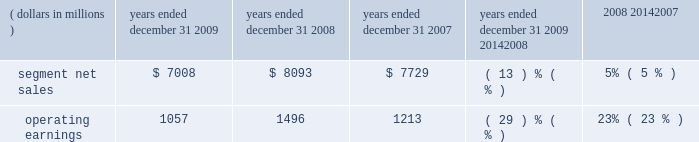Management 2019s discussion and analysis of financial condition and results of operations in 2008 , sales to the segment 2019s top five customers represented approximately 45% ( 45 % ) of the segment 2019s net sales .
The segment 2019s backlog was $ 2.3 billion at december 31 , 2008 , compared to $ 2.6 billion at december 31 , 2007 .
In 2008 , our digital video customers significantly increased their purchases of the segment 2019s products and services , primarily due to increased demand for digital entertainment devices , particularly ip and hd/dvr devices .
In february 2008 , the segment acquired the assets related to digital cable set-top products of zhejiang dahua digital technology co. , ltd and hangzhou image silicon ( known collectively as dahua digital ) , a developer , manufacturer and marketer of cable set-tops and related low-cost integrated circuits for the emerging chinese cable business .
The acquisition helped the segment strengthen its position in the rapidly growing cable market in china .
Enterprise mobility solutions segment the enterprise mobility solutions segment designs , manufactures , sells , installs and services analog and digital two-way radios , wireless lan and security products , voice and data communications products and systems for private networks , wireless broadband systems and end-to-end enterprise mobility solutions to a wide range of customers , including government and public safety agencies ( which , together with all sales to distributors of two-way communication products , are referred to as the 2018 2018government and public safety market 2019 2019 ) , as well as retail , energy and utilities , transportation , manufacturing , healthcare and other commercial customers ( which , collectively , are referred to as the 2018 2018commercial enterprise market 2019 2019 ) .
In 2009 , the segment 2019s net sales represented 32% ( 32 % ) of the company 2019s consolidated net sales , compared to 27% ( 27 % ) in 2008 and 21% ( 21 % ) in 2007 .
Years ended december 31 percent change ( dollars in millions ) 2009 2008 2007 2009 20142008 2008 20142007 .
Segment results 20142009 compared to 2008 in 2009 , the segment 2019s net sales were $ 7.0 billion , a decrease of 13% ( 13 % ) compared to net sales of $ 8.1 billion in 2008 .
The 13% ( 13 % ) decrease in net sales reflects a 21% ( 21 % ) decrease in net sales to the commercial enterprise market and a 10% ( 10 % ) decrease in net sales to the government and public safety market .
The decrease in net sales to the commercial enterprise market reflects decreased net sales in all regions .
The decrease in net sales to the government and public safety market was primarily driven by decreased net sales in emea , north america and latin america , partially offset by higher net sales in asia .
The segment 2019s overall net sales were lower in north america , emea and latin america and higher in asia the segment had operating earnings of $ 1.1 billion in 2009 , a decrease of 29% ( 29 % ) compared to operating earnings of $ 1.5 billion in 2008 .
The decrease in operating earnings was primarily due to a decrease in gross margin , driven by the 13% ( 13 % ) decrease in net sales and an unfavorable product mix .
Also contributing to the decrease in operating earnings was an increase in reorganization of business charges , relating primarily to higher employee severance costs .
These factors were partially offset by decreased sg&a expenses and r&d expenditures , primarily related to savings from cost-reduction initiatives .
As a percentage of net sales in 2009 as compared 2008 , gross margin decreased and r&d expenditures and sg&a expenses increased .
Net sales in north america continued to comprise a significant portion of the segment 2019s business , accounting for approximately 58% ( 58 % ) of the segment 2019s net sales in 2009 , compared to approximately 57% ( 57 % ) in 2008 .
The regional shift in 2009 as compared to 2008 reflects a 16% ( 16 % ) decline in net sales outside of north america and a 12% ( 12 % ) decline in net sales in north america .
The segment 2019s backlog was $ 2.4 billion at both december 31 , 2009 and december 31 , 2008 .
In our government and public safety market , we see a continued emphasis on mission-critical communication and homeland security solutions .
In 2009 , we led market innovation through the continued success of our mototrbo line and the delivery of the apx fffd family of products .
While spending by end customers in the segment 2019s government and public safety market is affected by government budgets at the national , state and local levels , we continue to see demand for large-scale mission critical communications systems .
In 2009 , we had significant wins across the globe , including several city and statewide communications systems in the united states , and continued success winning competitive projects with our tetra systems in europe , the middle east .
In 2007 what was the company 2019s consolidated net sales in millions? 
Computations: (7729 / 21%)
Answer: 36804.7619. 